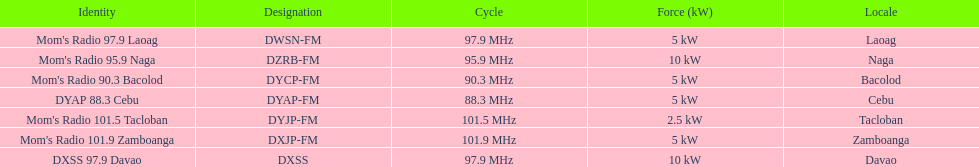What is the radio with the least about of mhz? DYAP 88.3 Cebu. 